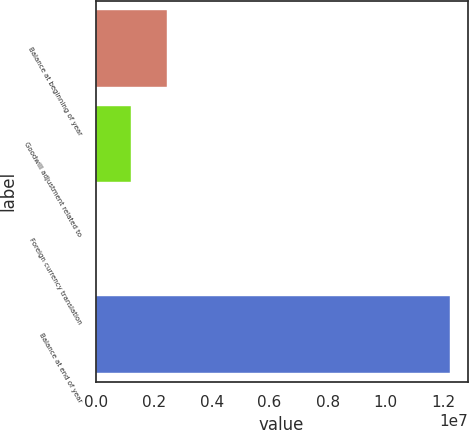Convert chart to OTSL. <chart><loc_0><loc_0><loc_500><loc_500><bar_chart><fcel>Balance at beginning of year<fcel>Goodwill adjustment related to<fcel>Foreign currency translation<fcel>Balance at end of year<nl><fcel>2.44499e+06<fcel>1.22343e+06<fcel>1869<fcel>1.22175e+07<nl></chart> 